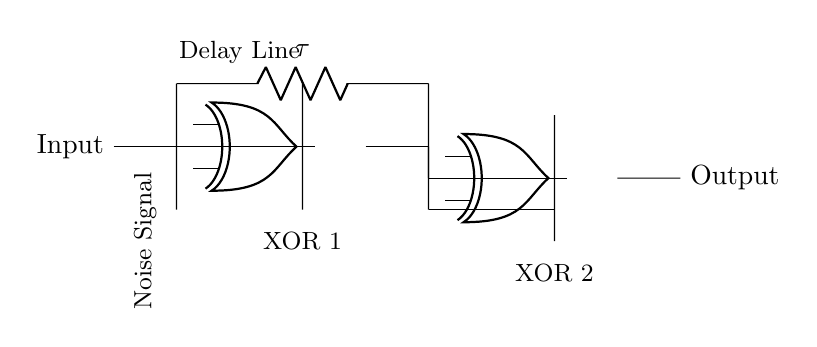What are the components used in this circuit? The components are two XOR gates and a delay line. The XOR gates process the signals, while the delay line introduces a time delay to one of the inputs.
Answer: Two XOR gates and one delay line What is the purpose of the delay line in this circuit? The delay line is used to create a phase difference between the input signals. This phase difference is essential for the XOR gates to process the input and noise signals effectively for noise cancellation.
Answer: To create a phase difference How many XOR gates are present in the circuit? There are two XOR gates in the circuit. Each gate takes inputs from the delay line and the original input signal.
Answer: Two What type of signal is connected to the input of the first XOR gate? The input signal is a noise signal, which is meant to be cancelled out. This noise signal will interact with the delayed version of itself to produce a useful output.
Answer: Noise signal What is the output of the second XOR gate when both inputs are the same? When both inputs to the second XOR gate are the same, the output will be low or zero. This important role is crucial for effective noise cancellation since it means that if the noise and its delayed version are identical, they will cancel out.
Answer: Zero How does the circuit utilize the XOR gates for noise cancellation? The XOR gates combine the original noise signal and a delayed version to determine if they are different. If they are different (i.e., noise is present), the output signal will be high, indicating a need for noise cancellation. If they are the same, the output will be low, which signifies the absence of noise.
Answer: By comparing input signals for cancellation 